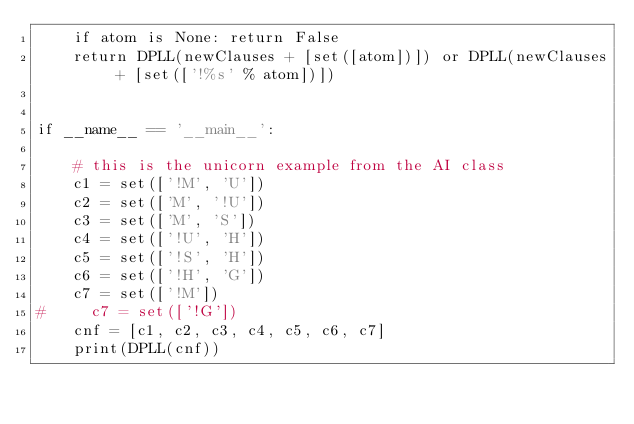Convert code to text. <code><loc_0><loc_0><loc_500><loc_500><_Python_>    if atom is None: return False
    return DPLL(newClauses + [set([atom])]) or DPLL(newClauses + [set(['!%s' % atom])])


if __name__ == '__main__':

    # this is the unicorn example from the AI class
    c1 = set(['!M', 'U'])
    c2 = set(['M', '!U'])
    c3 = set(['M', 'S'])
    c4 = set(['!U', 'H'])
    c5 = set(['!S', 'H'])
    c6 = set(['!H', 'G'])
    c7 = set(['!M'])
#     c7 = set(['!G'])
    cnf = [c1, c2, c3, c4, c5, c6, c7]
    print(DPLL(cnf))
                
            
            
    
        
    
    
    </code> 